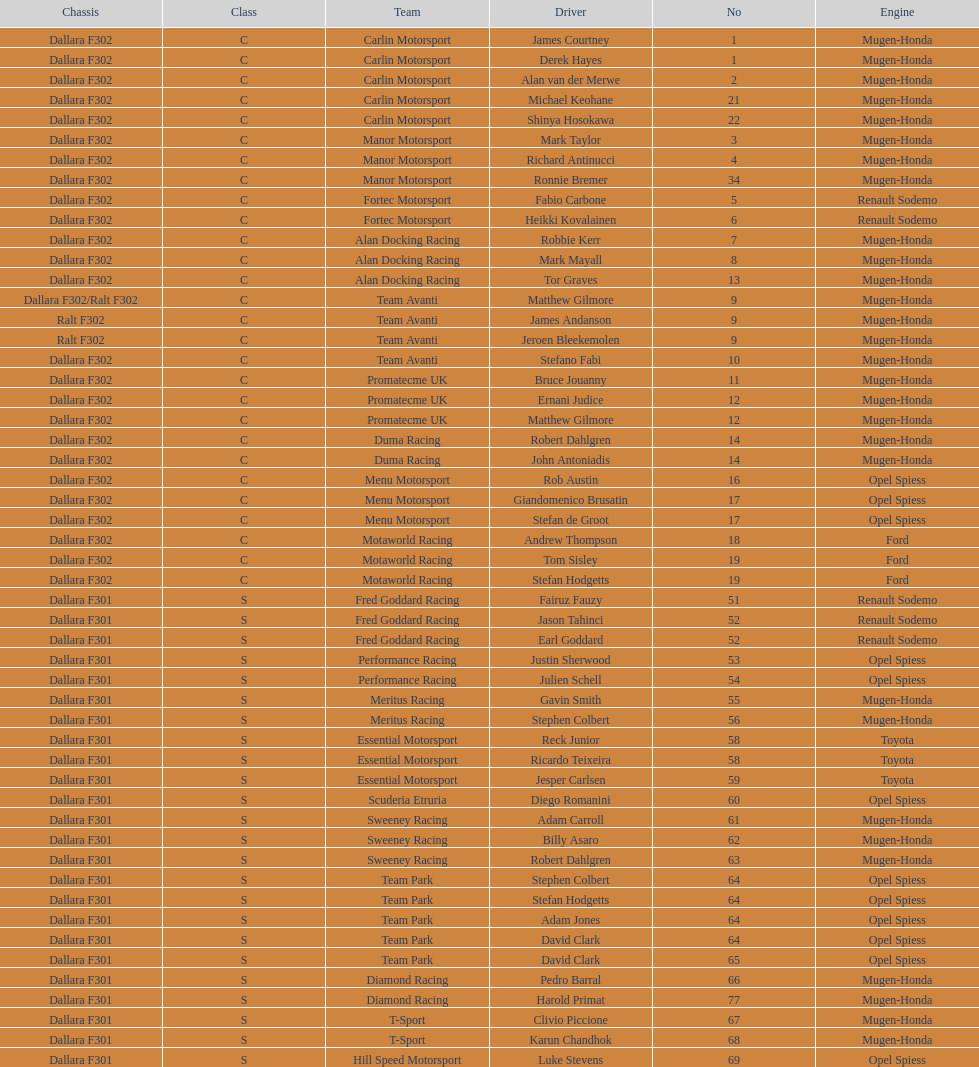The two drivers on t-sport are clivio piccione and what other driver? Karun Chandhok. 